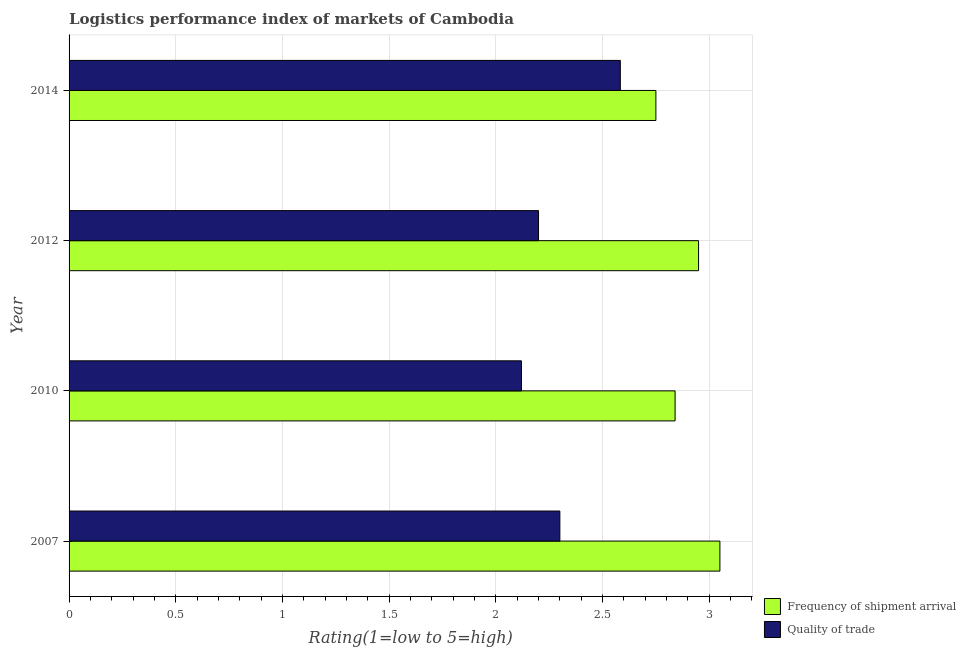How many different coloured bars are there?
Provide a succinct answer. 2. How many groups of bars are there?
Your answer should be compact. 4. How many bars are there on the 2nd tick from the bottom?
Ensure brevity in your answer.  2. What is the lpi quality of trade in 2010?
Your response must be concise. 2.12. Across all years, what is the maximum lpi of frequency of shipment arrival?
Provide a succinct answer. 3.05. Across all years, what is the minimum lpi quality of trade?
Your answer should be very brief. 2.12. What is the total lpi quality of trade in the graph?
Offer a terse response. 9.2. What is the difference between the lpi quality of trade in 2012 and that in 2014?
Provide a short and direct response. -0.38. What is the difference between the lpi quality of trade in 2012 and the lpi of frequency of shipment arrival in 2007?
Provide a short and direct response. -0.85. What is the average lpi of frequency of shipment arrival per year?
Provide a short and direct response. 2.9. In the year 2007, what is the difference between the lpi quality of trade and lpi of frequency of shipment arrival?
Offer a terse response. -0.75. What is the ratio of the lpi of frequency of shipment arrival in 2012 to that in 2014?
Your answer should be very brief. 1.07. Is the lpi quality of trade in 2012 less than that in 2014?
Your response must be concise. Yes. What is the difference between the highest and the second highest lpi quality of trade?
Keep it short and to the point. 0.28. What is the difference between the highest and the lowest lpi quality of trade?
Ensure brevity in your answer.  0.46. In how many years, is the lpi of frequency of shipment arrival greater than the average lpi of frequency of shipment arrival taken over all years?
Make the answer very short. 2. Is the sum of the lpi quality of trade in 2012 and 2014 greater than the maximum lpi of frequency of shipment arrival across all years?
Provide a short and direct response. Yes. What does the 2nd bar from the top in 2012 represents?
Make the answer very short. Frequency of shipment arrival. What does the 1st bar from the bottom in 2012 represents?
Ensure brevity in your answer.  Frequency of shipment arrival. What is the difference between two consecutive major ticks on the X-axis?
Provide a succinct answer. 0.5. What is the title of the graph?
Provide a succinct answer. Logistics performance index of markets of Cambodia. Does "Lowest 20% of population" appear as one of the legend labels in the graph?
Keep it short and to the point. No. What is the label or title of the X-axis?
Ensure brevity in your answer.  Rating(1=low to 5=high). What is the label or title of the Y-axis?
Your response must be concise. Year. What is the Rating(1=low to 5=high) of Frequency of shipment arrival in 2007?
Provide a succinct answer. 3.05. What is the Rating(1=low to 5=high) in Frequency of shipment arrival in 2010?
Keep it short and to the point. 2.84. What is the Rating(1=low to 5=high) in Quality of trade in 2010?
Your answer should be very brief. 2.12. What is the Rating(1=low to 5=high) in Frequency of shipment arrival in 2012?
Make the answer very short. 2.95. What is the Rating(1=low to 5=high) in Quality of trade in 2012?
Your answer should be very brief. 2.2. What is the Rating(1=low to 5=high) of Frequency of shipment arrival in 2014?
Keep it short and to the point. 2.75. What is the Rating(1=low to 5=high) of Quality of trade in 2014?
Make the answer very short. 2.58. Across all years, what is the maximum Rating(1=low to 5=high) of Frequency of shipment arrival?
Make the answer very short. 3.05. Across all years, what is the maximum Rating(1=low to 5=high) in Quality of trade?
Offer a very short reply. 2.58. Across all years, what is the minimum Rating(1=low to 5=high) of Frequency of shipment arrival?
Offer a very short reply. 2.75. Across all years, what is the minimum Rating(1=low to 5=high) of Quality of trade?
Ensure brevity in your answer.  2.12. What is the total Rating(1=low to 5=high) in Frequency of shipment arrival in the graph?
Provide a short and direct response. 11.59. What is the total Rating(1=low to 5=high) of Quality of trade in the graph?
Your answer should be compact. 9.2. What is the difference between the Rating(1=low to 5=high) in Frequency of shipment arrival in 2007 and that in 2010?
Offer a terse response. 0.21. What is the difference between the Rating(1=low to 5=high) in Quality of trade in 2007 and that in 2010?
Your answer should be very brief. 0.18. What is the difference between the Rating(1=low to 5=high) of Frequency of shipment arrival in 2007 and that in 2012?
Provide a succinct answer. 0.1. What is the difference between the Rating(1=low to 5=high) of Quality of trade in 2007 and that in 2014?
Offer a very short reply. -0.28. What is the difference between the Rating(1=low to 5=high) in Frequency of shipment arrival in 2010 and that in 2012?
Offer a very short reply. -0.11. What is the difference between the Rating(1=low to 5=high) of Quality of trade in 2010 and that in 2012?
Keep it short and to the point. -0.08. What is the difference between the Rating(1=low to 5=high) of Frequency of shipment arrival in 2010 and that in 2014?
Provide a succinct answer. 0.09. What is the difference between the Rating(1=low to 5=high) in Quality of trade in 2010 and that in 2014?
Your answer should be very brief. -0.46. What is the difference between the Rating(1=low to 5=high) in Quality of trade in 2012 and that in 2014?
Your response must be concise. -0.38. What is the difference between the Rating(1=low to 5=high) of Frequency of shipment arrival in 2007 and the Rating(1=low to 5=high) of Quality of trade in 2012?
Your answer should be compact. 0.85. What is the difference between the Rating(1=low to 5=high) of Frequency of shipment arrival in 2007 and the Rating(1=low to 5=high) of Quality of trade in 2014?
Make the answer very short. 0.47. What is the difference between the Rating(1=low to 5=high) in Frequency of shipment arrival in 2010 and the Rating(1=low to 5=high) in Quality of trade in 2012?
Your response must be concise. 0.64. What is the difference between the Rating(1=low to 5=high) in Frequency of shipment arrival in 2010 and the Rating(1=low to 5=high) in Quality of trade in 2014?
Ensure brevity in your answer.  0.26. What is the difference between the Rating(1=low to 5=high) in Frequency of shipment arrival in 2012 and the Rating(1=low to 5=high) in Quality of trade in 2014?
Provide a short and direct response. 0.37. What is the average Rating(1=low to 5=high) in Frequency of shipment arrival per year?
Your response must be concise. 2.9. What is the average Rating(1=low to 5=high) in Quality of trade per year?
Your answer should be very brief. 2.3. In the year 2007, what is the difference between the Rating(1=low to 5=high) in Frequency of shipment arrival and Rating(1=low to 5=high) in Quality of trade?
Offer a terse response. 0.75. In the year 2010, what is the difference between the Rating(1=low to 5=high) in Frequency of shipment arrival and Rating(1=low to 5=high) in Quality of trade?
Make the answer very short. 0.72. In the year 2012, what is the difference between the Rating(1=low to 5=high) of Frequency of shipment arrival and Rating(1=low to 5=high) of Quality of trade?
Your answer should be very brief. 0.75. In the year 2014, what is the difference between the Rating(1=low to 5=high) of Frequency of shipment arrival and Rating(1=low to 5=high) of Quality of trade?
Provide a short and direct response. 0.17. What is the ratio of the Rating(1=low to 5=high) of Frequency of shipment arrival in 2007 to that in 2010?
Your answer should be compact. 1.07. What is the ratio of the Rating(1=low to 5=high) in Quality of trade in 2007 to that in 2010?
Offer a very short reply. 1.08. What is the ratio of the Rating(1=low to 5=high) of Frequency of shipment arrival in 2007 to that in 2012?
Give a very brief answer. 1.03. What is the ratio of the Rating(1=low to 5=high) of Quality of trade in 2007 to that in 2012?
Keep it short and to the point. 1.05. What is the ratio of the Rating(1=low to 5=high) in Frequency of shipment arrival in 2007 to that in 2014?
Offer a terse response. 1.11. What is the ratio of the Rating(1=low to 5=high) of Quality of trade in 2007 to that in 2014?
Provide a short and direct response. 0.89. What is the ratio of the Rating(1=low to 5=high) in Frequency of shipment arrival in 2010 to that in 2012?
Provide a short and direct response. 0.96. What is the ratio of the Rating(1=low to 5=high) of Quality of trade in 2010 to that in 2012?
Provide a short and direct response. 0.96. What is the ratio of the Rating(1=low to 5=high) of Frequency of shipment arrival in 2010 to that in 2014?
Keep it short and to the point. 1.03. What is the ratio of the Rating(1=low to 5=high) of Quality of trade in 2010 to that in 2014?
Provide a succinct answer. 0.82. What is the ratio of the Rating(1=low to 5=high) of Frequency of shipment arrival in 2012 to that in 2014?
Offer a very short reply. 1.07. What is the ratio of the Rating(1=low to 5=high) of Quality of trade in 2012 to that in 2014?
Your answer should be compact. 0.85. What is the difference between the highest and the second highest Rating(1=low to 5=high) of Quality of trade?
Your answer should be very brief. 0.28. What is the difference between the highest and the lowest Rating(1=low to 5=high) of Quality of trade?
Provide a succinct answer. 0.46. 